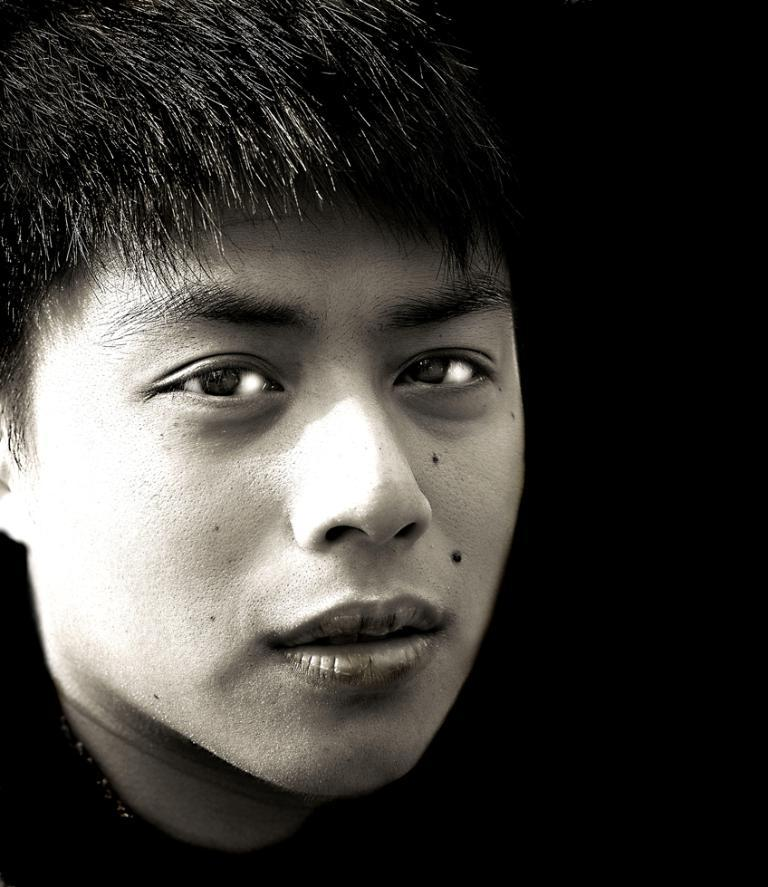What is happening in the image? There is a person in the image who is posing for a photo. What can be observed about the background of the image? The background of the image is black. How is the image presented in terms of color? The image is black and white. What type of toothpaste is being used by the person in the image? There is no toothpaste present in the image, as it features a person posing for a photo with a black background in black and white. 